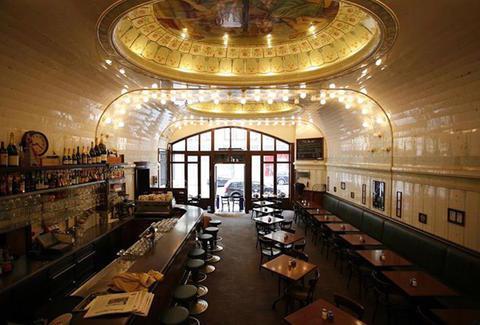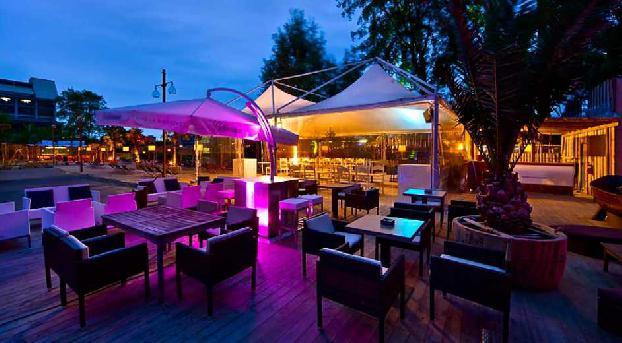The first image is the image on the left, the second image is the image on the right. Considering the images on both sides, is "In at least one of the images all the chairs are empty." valid? Answer yes or no. Yes. The first image is the image on the left, the second image is the image on the right. Assess this claim about the two images: "One image shows customers in a restaurant and the other shows no customers.". Correct or not? Answer yes or no. No. 